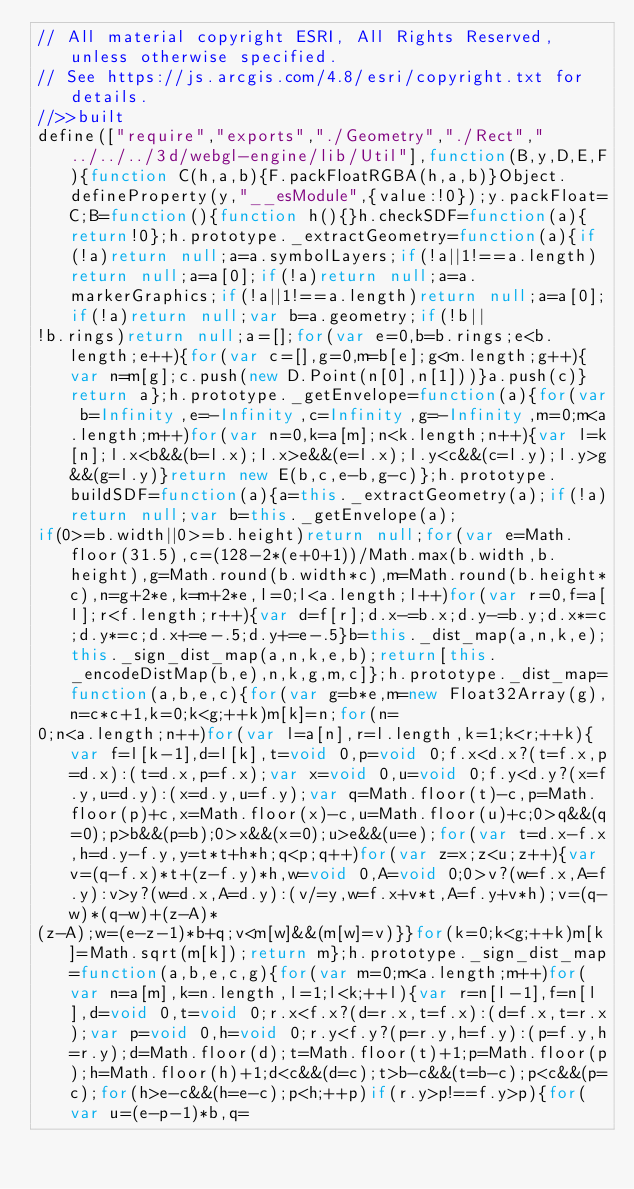<code> <loc_0><loc_0><loc_500><loc_500><_JavaScript_>// All material copyright ESRI, All Rights Reserved, unless otherwise specified.
// See https://js.arcgis.com/4.8/esri/copyright.txt for details.
//>>built
define(["require","exports","./Geometry","./Rect","../../../3d/webgl-engine/lib/Util"],function(B,y,D,E,F){function C(h,a,b){F.packFloatRGBA(h,a,b)}Object.defineProperty(y,"__esModule",{value:!0});y.packFloat=C;B=function(){function h(){}h.checkSDF=function(a){return!0};h.prototype._extractGeometry=function(a){if(!a)return null;a=a.symbolLayers;if(!a||1!==a.length)return null;a=a[0];if(!a)return null;a=a.markerGraphics;if(!a||1!==a.length)return null;a=a[0];if(!a)return null;var b=a.geometry;if(!b||
!b.rings)return null;a=[];for(var e=0,b=b.rings;e<b.length;e++){for(var c=[],g=0,m=b[e];g<m.length;g++){var n=m[g];c.push(new D.Point(n[0],n[1]))}a.push(c)}return a};h.prototype._getEnvelope=function(a){for(var b=Infinity,e=-Infinity,c=Infinity,g=-Infinity,m=0;m<a.length;m++)for(var n=0,k=a[m];n<k.length;n++){var l=k[n];l.x<b&&(b=l.x);l.x>e&&(e=l.x);l.y<c&&(c=l.y);l.y>g&&(g=l.y)}return new E(b,c,e-b,g-c)};h.prototype.buildSDF=function(a){a=this._extractGeometry(a);if(!a)return null;var b=this._getEnvelope(a);
if(0>=b.width||0>=b.height)return null;for(var e=Math.floor(31.5),c=(128-2*(e+0+1))/Math.max(b.width,b.height),g=Math.round(b.width*c),m=Math.round(b.height*c),n=g+2*e,k=m+2*e,l=0;l<a.length;l++)for(var r=0,f=a[l];r<f.length;r++){var d=f[r];d.x-=b.x;d.y-=b.y;d.x*=c;d.y*=c;d.x+=e-.5;d.y+=e-.5}b=this._dist_map(a,n,k,e);this._sign_dist_map(a,n,k,e,b);return[this._encodeDistMap(b,e),n,k,g,m,c]};h.prototype._dist_map=function(a,b,e,c){for(var g=b*e,m=new Float32Array(g),n=c*c+1,k=0;k<g;++k)m[k]=n;for(n=
0;n<a.length;n++)for(var l=a[n],r=l.length,k=1;k<r;++k){var f=l[k-1],d=l[k],t=void 0,p=void 0;f.x<d.x?(t=f.x,p=d.x):(t=d.x,p=f.x);var x=void 0,u=void 0;f.y<d.y?(x=f.y,u=d.y):(x=d.y,u=f.y);var q=Math.floor(t)-c,p=Math.floor(p)+c,x=Math.floor(x)-c,u=Math.floor(u)+c;0>q&&(q=0);p>b&&(p=b);0>x&&(x=0);u>e&&(u=e);for(var t=d.x-f.x,h=d.y-f.y,y=t*t+h*h;q<p;q++)for(var z=x;z<u;z++){var v=(q-f.x)*t+(z-f.y)*h,w=void 0,A=void 0;0>v?(w=f.x,A=f.y):v>y?(w=d.x,A=d.y):(v/=y,w=f.x+v*t,A=f.y+v*h);v=(q-w)*(q-w)+(z-A)*
(z-A);w=(e-z-1)*b+q;v<m[w]&&(m[w]=v)}}for(k=0;k<g;++k)m[k]=Math.sqrt(m[k]);return m};h.prototype._sign_dist_map=function(a,b,e,c,g){for(var m=0;m<a.length;m++)for(var n=a[m],k=n.length,l=1;l<k;++l){var r=n[l-1],f=n[l],d=void 0,t=void 0;r.x<f.x?(d=r.x,t=f.x):(d=f.x,t=r.x);var p=void 0,h=void 0;r.y<f.y?(p=r.y,h=f.y):(p=f.y,h=r.y);d=Math.floor(d);t=Math.floor(t)+1;p=Math.floor(p);h=Math.floor(h)+1;d<c&&(d=c);t>b-c&&(t=b-c);p<c&&(p=c);for(h>e-c&&(h=e-c);p<h;++p)if(r.y>p!==f.y>p){for(var u=(e-p-1)*b,q=</code> 